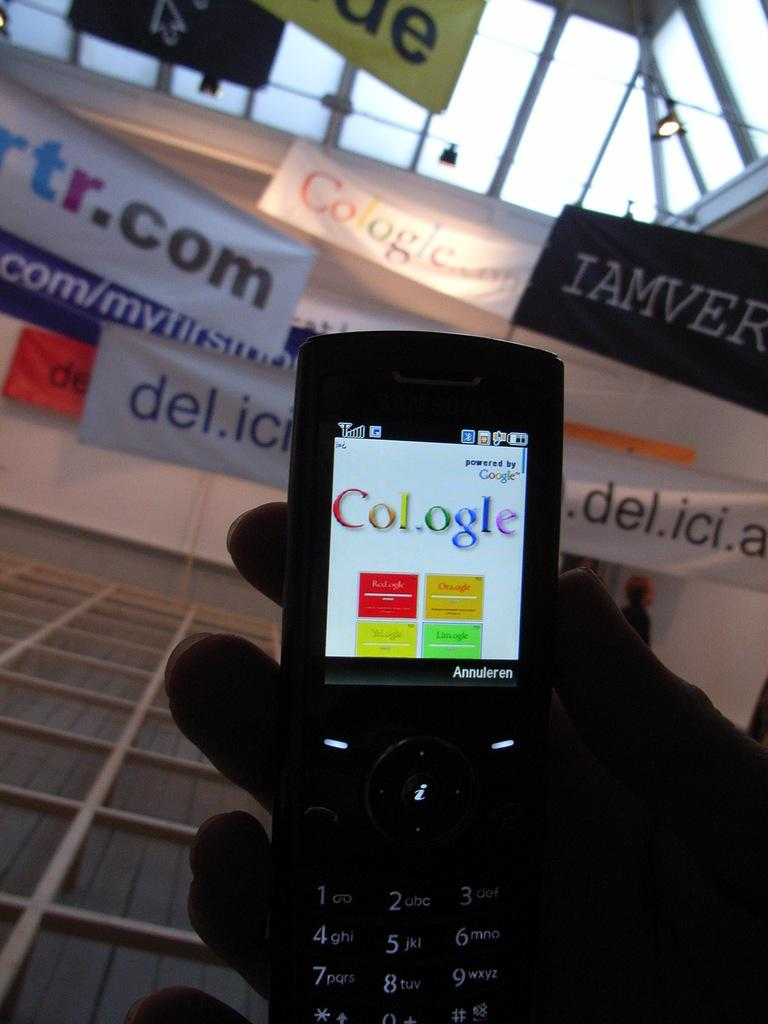<image>
Create a compact narrative representing the image presented. A person is holding a cell phone that says Cologle on the screen. 